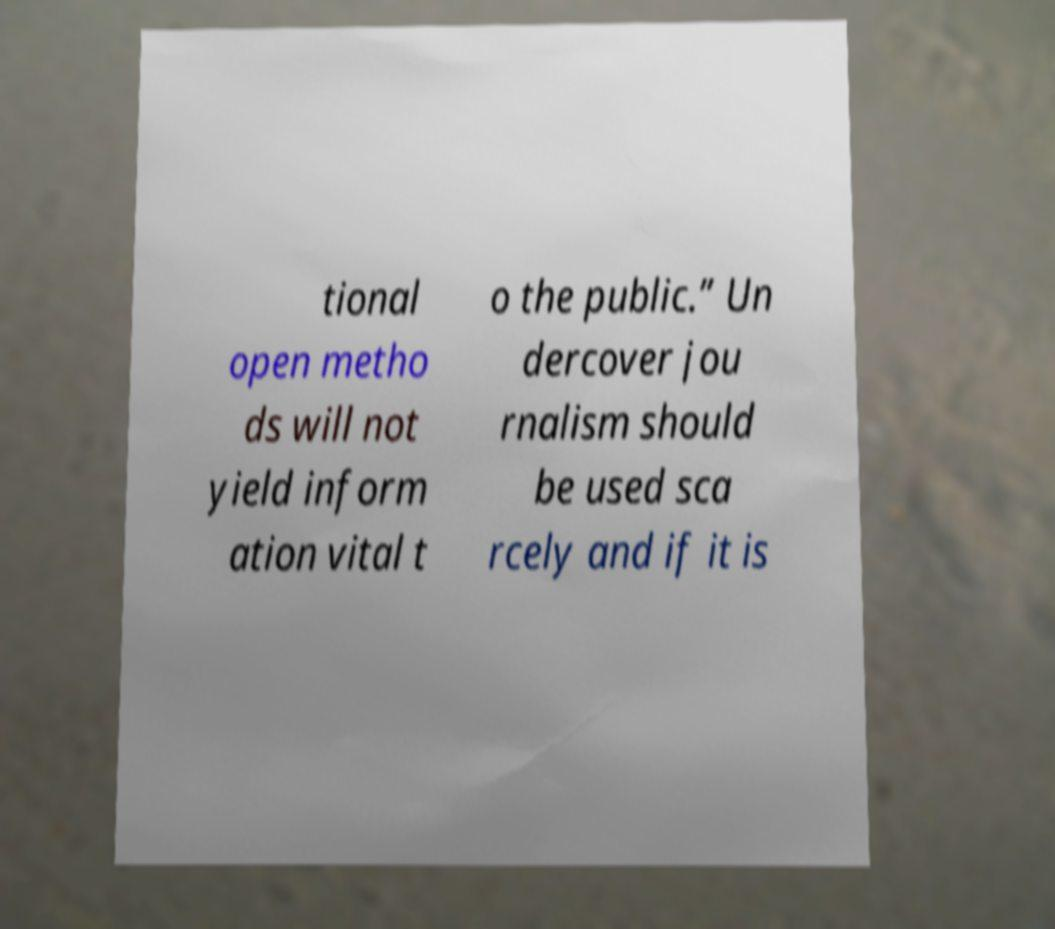There's text embedded in this image that I need extracted. Can you transcribe it verbatim? tional open metho ds will not yield inform ation vital t o the public.” Un dercover jou rnalism should be used sca rcely and if it is 